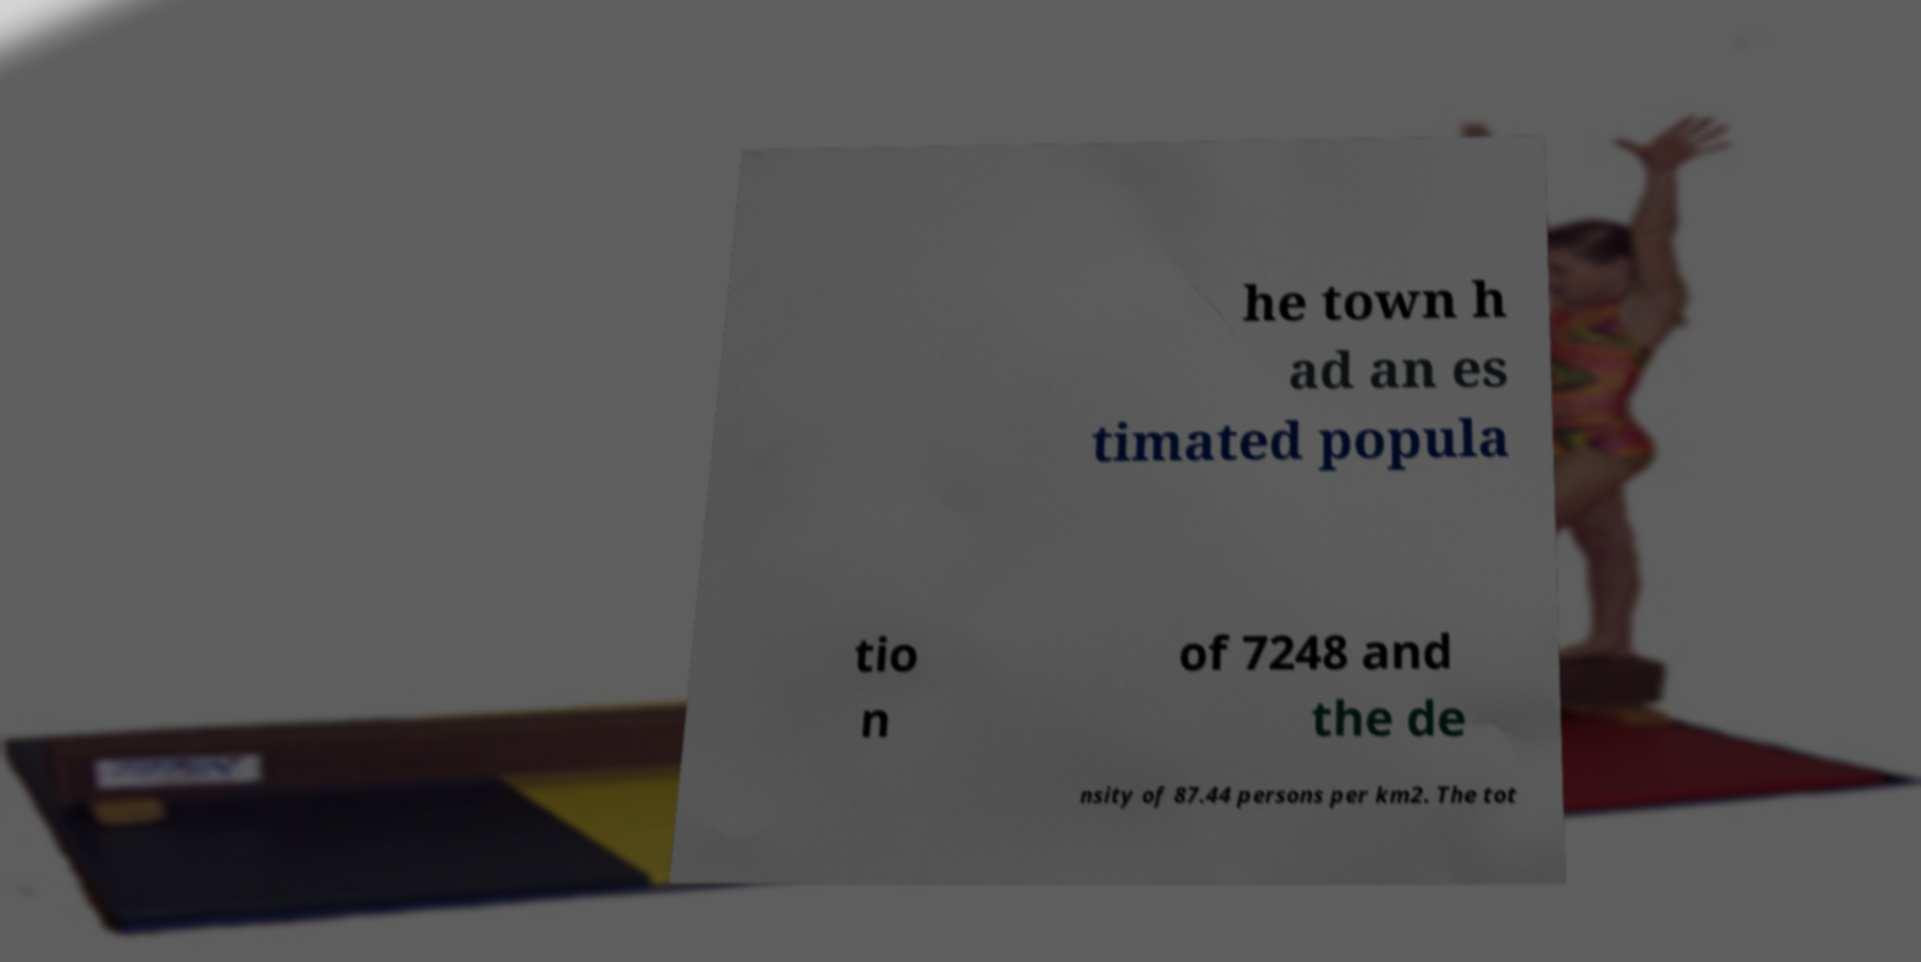Can you accurately transcribe the text from the provided image for me? he town h ad an es timated popula tio n of 7248 and the de nsity of 87.44 persons per km2. The tot 